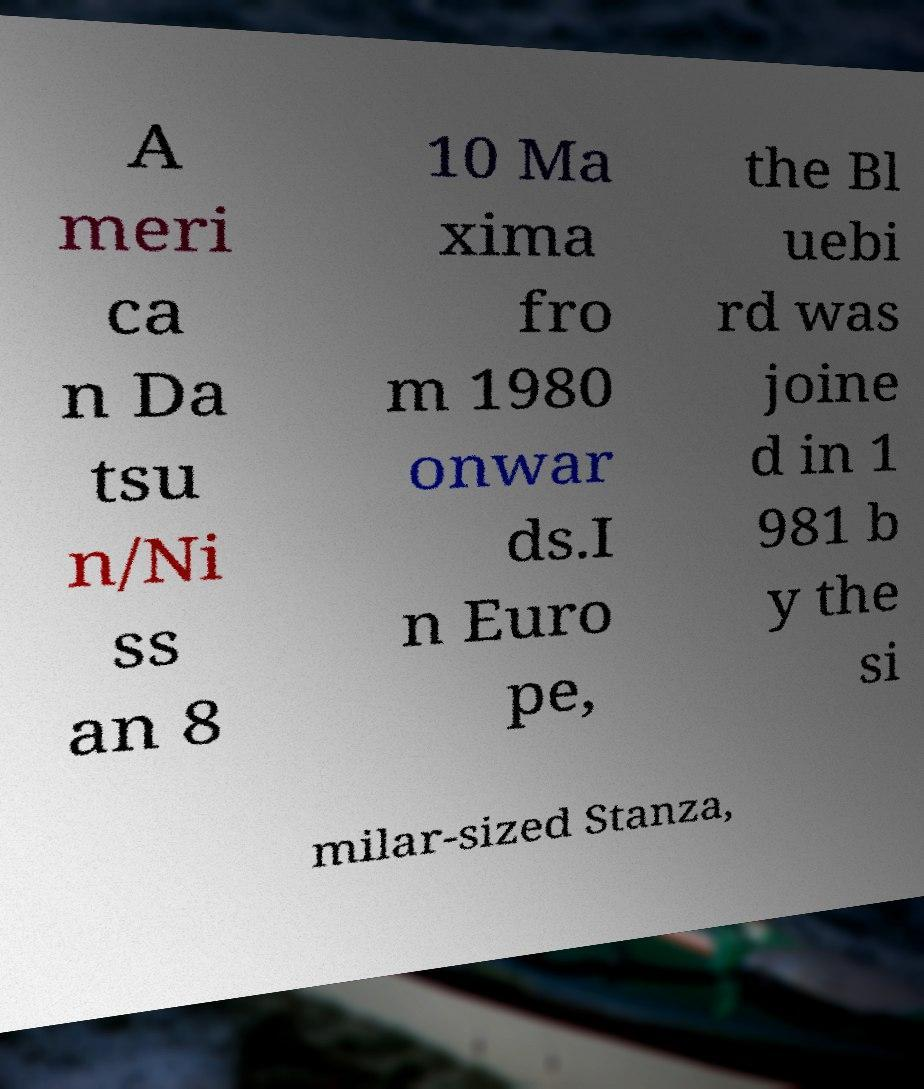Could you assist in decoding the text presented in this image and type it out clearly? A meri ca n Da tsu n/Ni ss an 8 10 Ma xima fro m 1980 onwar ds.I n Euro pe, the Bl uebi rd was joine d in 1 981 b y the si milar-sized Stanza, 